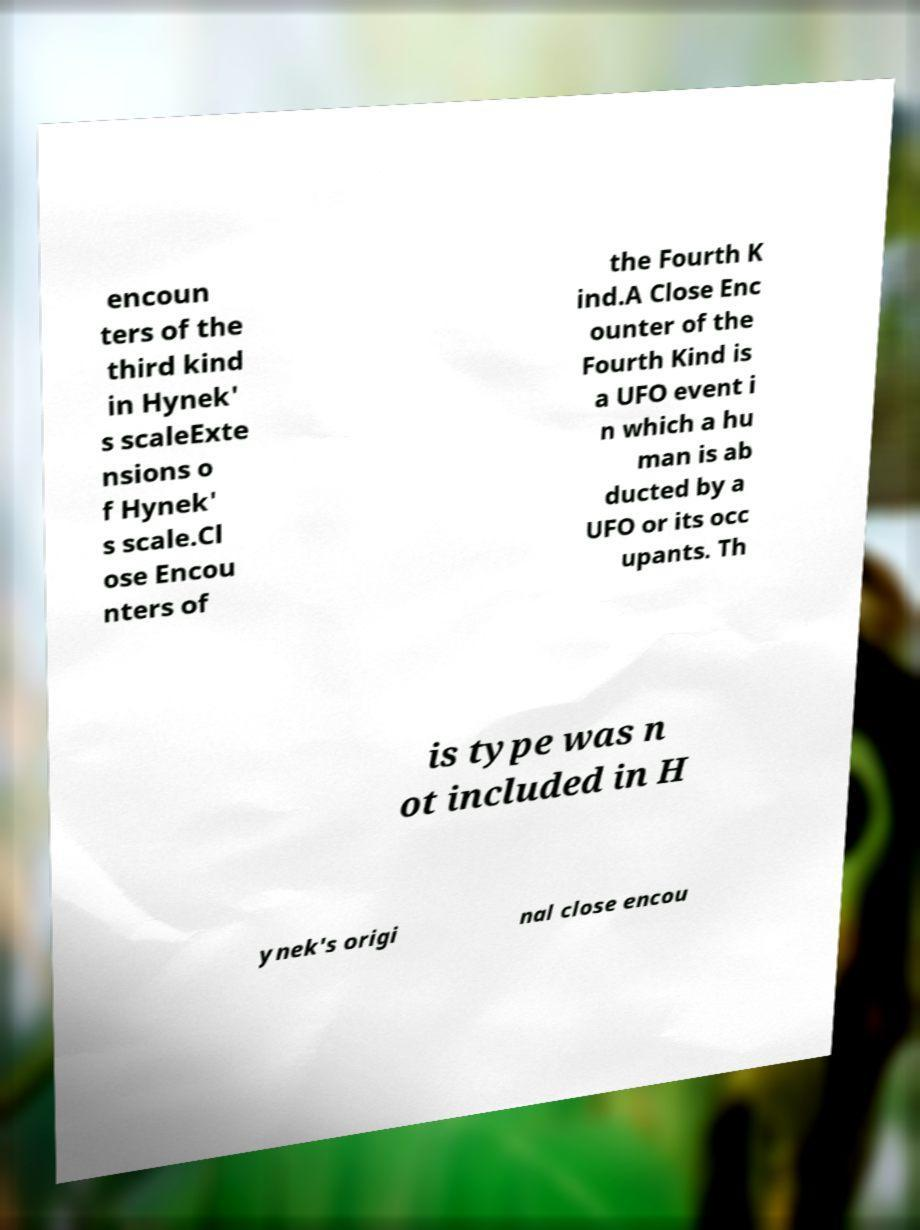Please read and relay the text visible in this image. What does it say? encoun ters of the third kind in Hynek' s scaleExte nsions o f Hynek' s scale.Cl ose Encou nters of the Fourth K ind.A Close Enc ounter of the Fourth Kind is a UFO event i n which a hu man is ab ducted by a UFO or its occ upants. Th is type was n ot included in H ynek's origi nal close encou 